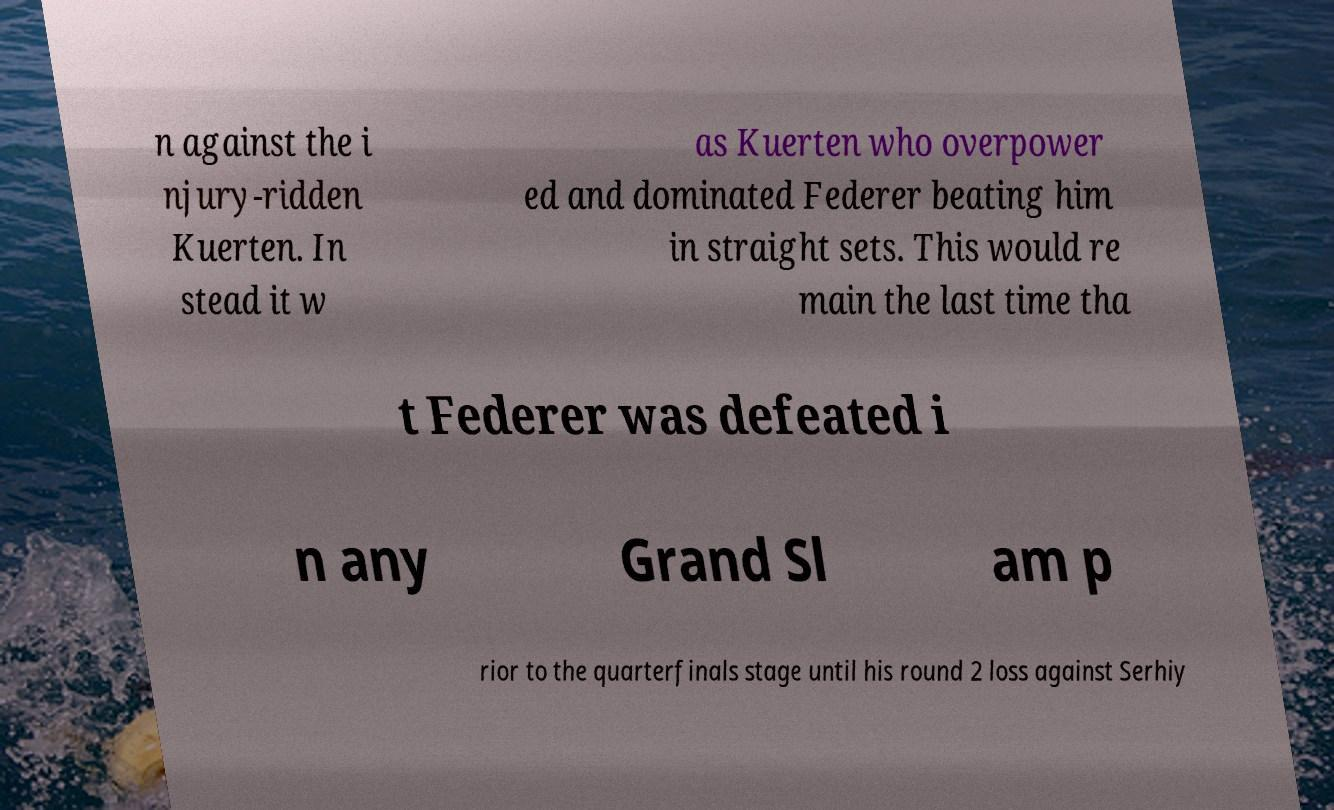There's text embedded in this image that I need extracted. Can you transcribe it verbatim? n against the i njury-ridden Kuerten. In stead it w as Kuerten who overpower ed and dominated Federer beating him in straight sets. This would re main the last time tha t Federer was defeated i n any Grand Sl am p rior to the quarterfinals stage until his round 2 loss against Serhiy 